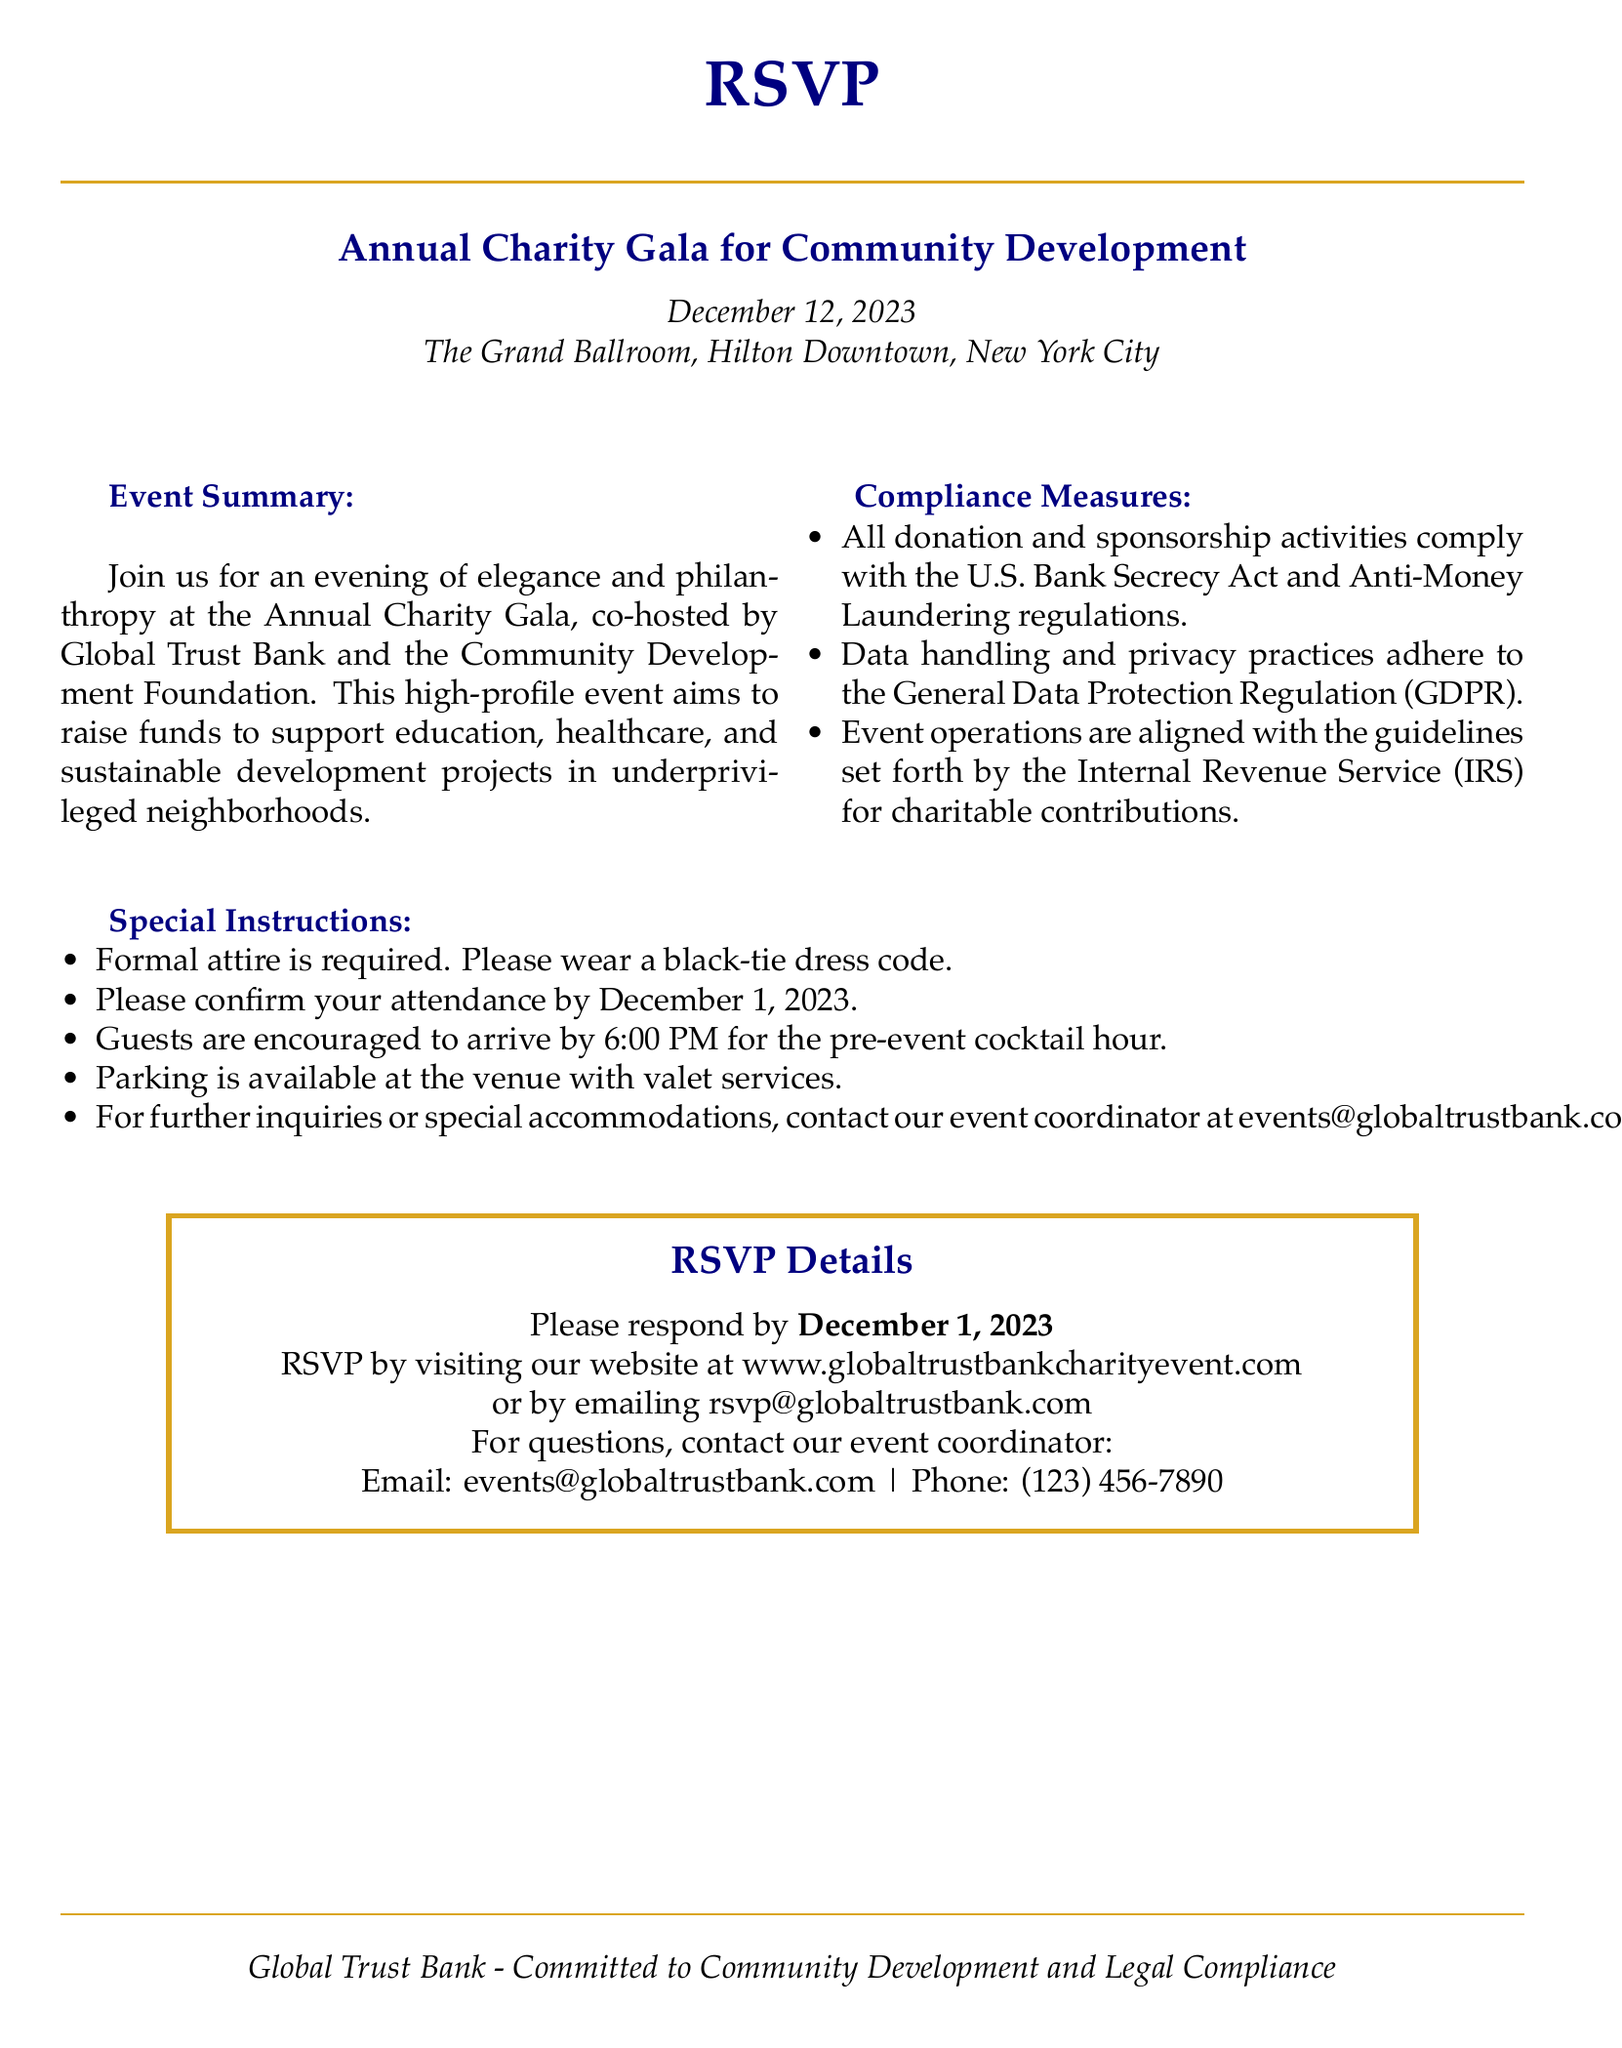What is the date of the charity event? The date is explicitly mentioned in the document as December 12, 2023.
Answer: December 12, 2023 What is the venue of the event? The venue is provided in the heading section of the document as The Grand Ballroom, Hilton Downtown, New York City.
Answer: The Grand Ballroom, Hilton Downtown, New York City Who are the co-hosts of the event? The co-hosts are stated in the event summary and are Global Trust Bank and the Community Development Foundation.
Answer: Global Trust Bank and the Community Development Foundation What attire is required for the event? The special instructions section specifies that formal attire is required and notes a black-tie dress code.
Answer: Black-tie What is the RSVP deadline? The document clearly states that attendees must confirm their attendance by December 1, 2023.
Answer: December 1, 2023 Which regulation is mentioned regarding donation activities? The compliance measures section mentions that all donation activities comply with the U.S. Bank Secrecy Act and Anti-Money Laundering regulations.
Answer: U.S. Bank Secrecy Act and Anti-Money Laundering What time should guests arrive for the cocktail hour? The special instructions indicate that guests are encouraged to arrive by 6:00 PM for the pre-event cocktail hour.
Answer: 6:00 PM How can guests RSVP? The RSVP details section outlines that guests can respond by visiting the website or emailing the provided email address.
Answer: Website or emailing rsvp@globaltrustbank.com 